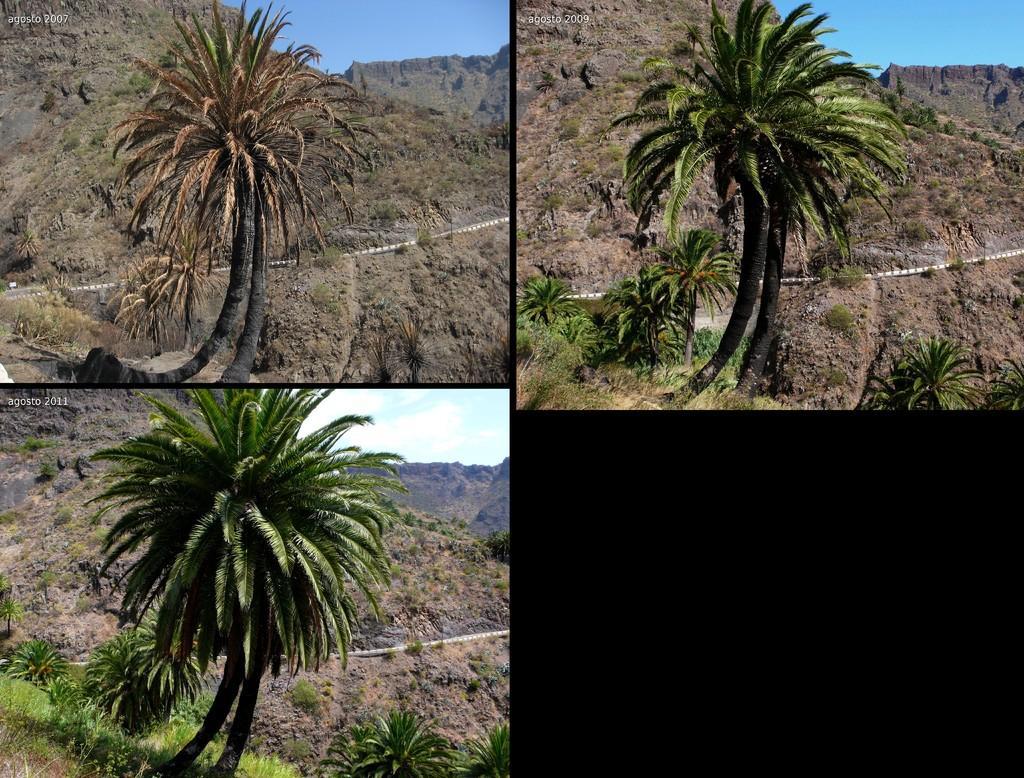Please provide a concise description of this image. In this image there is a collage, there is the sky, there are clouds in the sky, there are mountains, there are trees, there is text towards the top of the image, there are plants towards the bottom of the image, the bottom of the image is dark. 